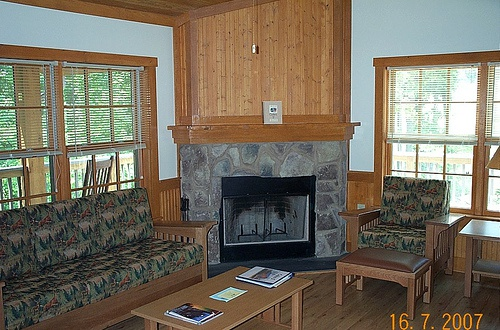Describe the objects in this image and their specific colors. I can see couch in gray, black, and maroon tones, dining table in gray, brown, and black tones, chair in gray and black tones, chair in gray, maroon, and black tones, and book in gray, darkgray, black, and lightblue tones in this image. 